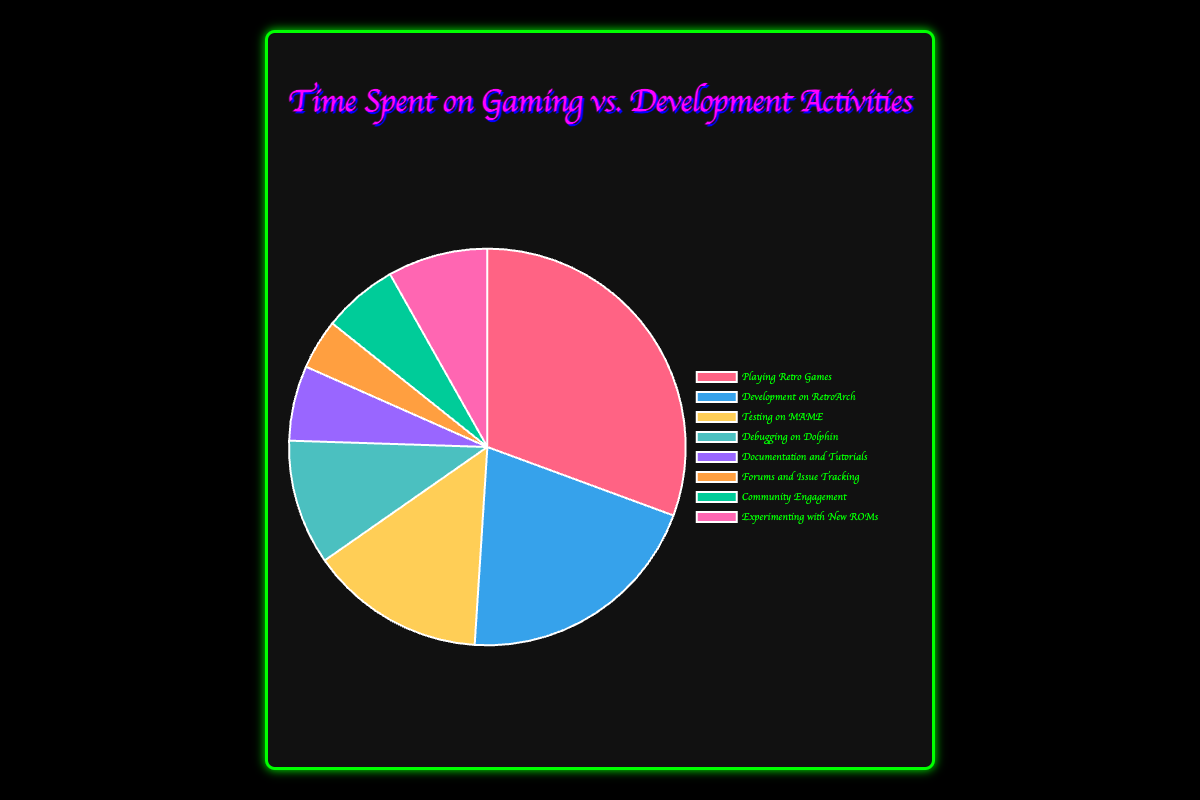What's the total time spent on development-related activities? Summing up the time spent on Development on RetroArch, Testing on MAME, Debugging on Dolphin, Documentation and Tutorials, Forums and Issue Tracking, and Community Engagement: 10 + 7 + 5 + 3 + 2 + 3 = 30 hours.
Answer: 30 hours Which activity consumes the most time? The 'Playing Retro Games' activity has the highest time spent at 15 hours according to the chart data.
Answer: Playing Retro Games How does the time spent on Testing on MAME compare with Debugging on Dolphin? Testing on MAME has 7 hours, while Debugging on Dolphin has 5 hours. Therefore, Testing on MAME takes more time.
Answer: More Which activity has the least time allocation? 'Forums and Issue Tracking' has the least time allocation at 2 hours as per the chart data.
Answer: Forums and Issue Tracking What's the combined time spent on Playing Retro Games and Development on RetroArch? Adding time spent on Playing Retro Games (15 hours) and Development on RetroArch (10 hours): 15 + 10 = 25 hours.
Answer: 25 hours How does the time spent on Experimenting with New ROMs compare with that on Documentation and Tutorials? Experimenting with New ROMs has 4 hours while Documentation and Tutorials has 3 hours, hence Experimenting with New ROMs takes more time.
Answer: More What fraction of total time is spent on Community Engagement? Total time is 49 hours. Time spent on Community Engagement is 3 hours. Therefore, the fraction is 3/49.
Answer: 3/49 What is the average time spent on activities excluding Playing Retro Games? Total time excluding Playing Retro Games: 10 + 7 + 5 + 3 + 2 + 3 + 4 = 34 hours. Number of activities: 7. Average = 34 / 7 ≈ 4.86 hours.
Answer: 4.86 hours Which activity represented by the color blue? According to the chart, the color blue corresponds to 'Development on RetroArch'.
Answer: Development on RetroArch 